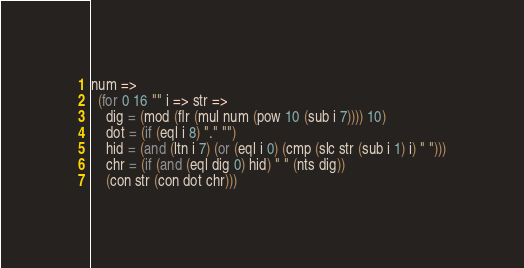<code> <loc_0><loc_0><loc_500><loc_500><_MoonScript_>num =>
  (for 0 16 "" i => str =>
    dig = (mod (flr (mul num (pow 10 (sub i 7)))) 10)
    dot = (if (eql i 8) "." "")
    hid = (and (ltn i 7) (or (eql i 0) (cmp (slc str (sub i 1) i) " ")))
    chr = (if (and (eql dig 0) hid) " " (nts dig)) 
    (con str (con dot chr)))
</code> 